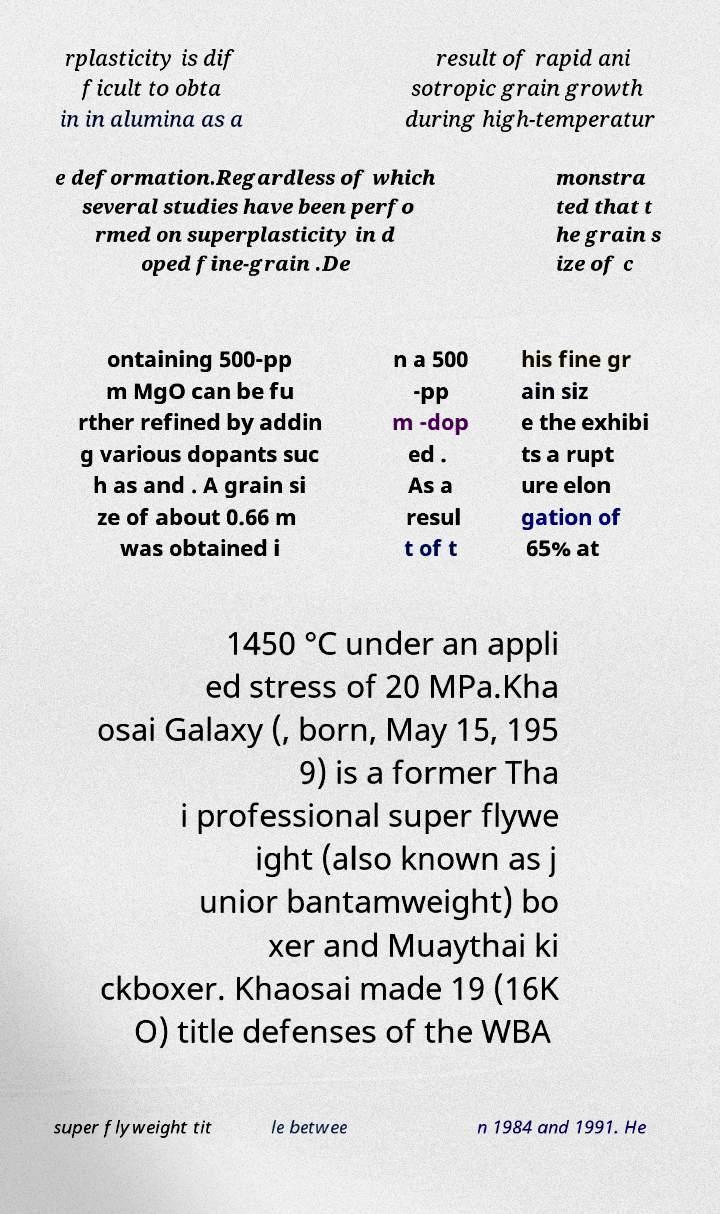Can you read and provide the text displayed in the image?This photo seems to have some interesting text. Can you extract and type it out for me? rplasticity is dif ficult to obta in in alumina as a result of rapid ani sotropic grain growth during high-temperatur e deformation.Regardless of which several studies have been perfo rmed on superplasticity in d oped fine-grain .De monstra ted that t he grain s ize of c ontaining 500-pp m MgO can be fu rther refined by addin g various dopants suc h as and . A grain si ze of about 0.66 m was obtained i n a 500 -pp m -dop ed . As a resul t of t his fine gr ain siz e the exhibi ts a rupt ure elon gation of 65% at 1450 °C under an appli ed stress of 20 MPa.Kha osai Galaxy (, born, May 15, 195 9) is a former Tha i professional super flywe ight (also known as j unior bantamweight) bo xer and Muaythai ki ckboxer. Khaosai made 19 (16K O) title defenses of the WBA super flyweight tit le betwee n 1984 and 1991. He 